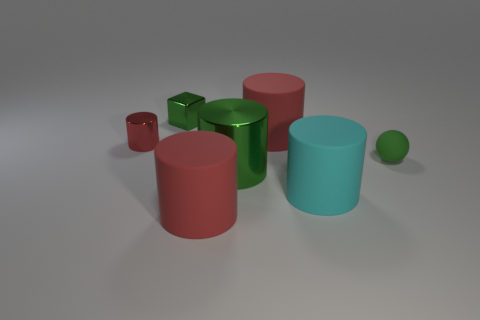Is there any other thing that has the same shape as the tiny green matte object?
Your response must be concise. No. How many cylinders are small shiny objects or large green metal objects?
Ensure brevity in your answer.  2. How many things are both behind the green matte ball and in front of the green rubber object?
Make the answer very short. 0. The large rubber cylinder behind the matte ball is what color?
Make the answer very short. Red. What size is the red cylinder that is made of the same material as the green cylinder?
Provide a succinct answer. Small. How many red metal objects are right of the large green metal thing that is in front of the sphere?
Offer a terse response. 0. What number of tiny red shiny objects are on the left side of the big green cylinder?
Make the answer very short. 1. There is a metal cylinder behind the tiny object to the right of the large green cylinder that is right of the red shiny thing; what color is it?
Your response must be concise. Red. There is a big matte thing that is in front of the large cyan rubber thing; is its color the same as the tiny matte ball that is right of the tiny red metal cylinder?
Your answer should be compact. No. What is the shape of the green metal thing in front of the big cylinder behind the green matte ball?
Give a very brief answer. Cylinder. 